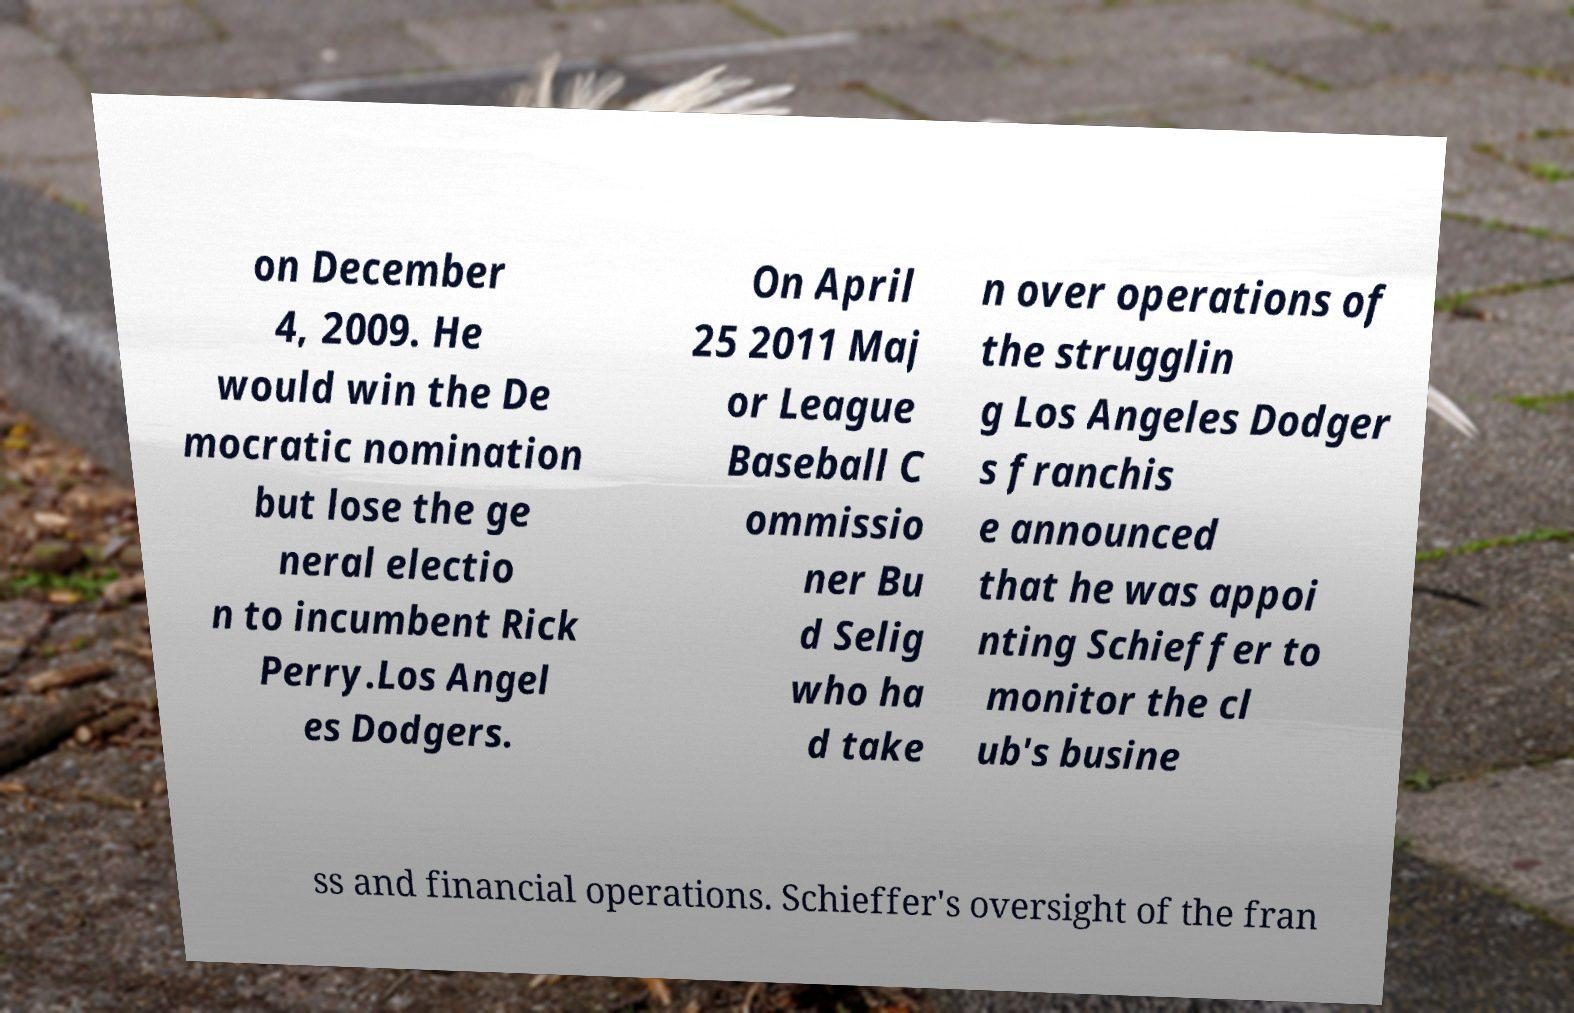There's text embedded in this image that I need extracted. Can you transcribe it verbatim? on December 4, 2009. He would win the De mocratic nomination but lose the ge neral electio n to incumbent Rick Perry.Los Angel es Dodgers. On April 25 2011 Maj or League Baseball C ommissio ner Bu d Selig who ha d take n over operations of the strugglin g Los Angeles Dodger s franchis e announced that he was appoi nting Schieffer to monitor the cl ub's busine ss and financial operations. Schieffer's oversight of the fran 